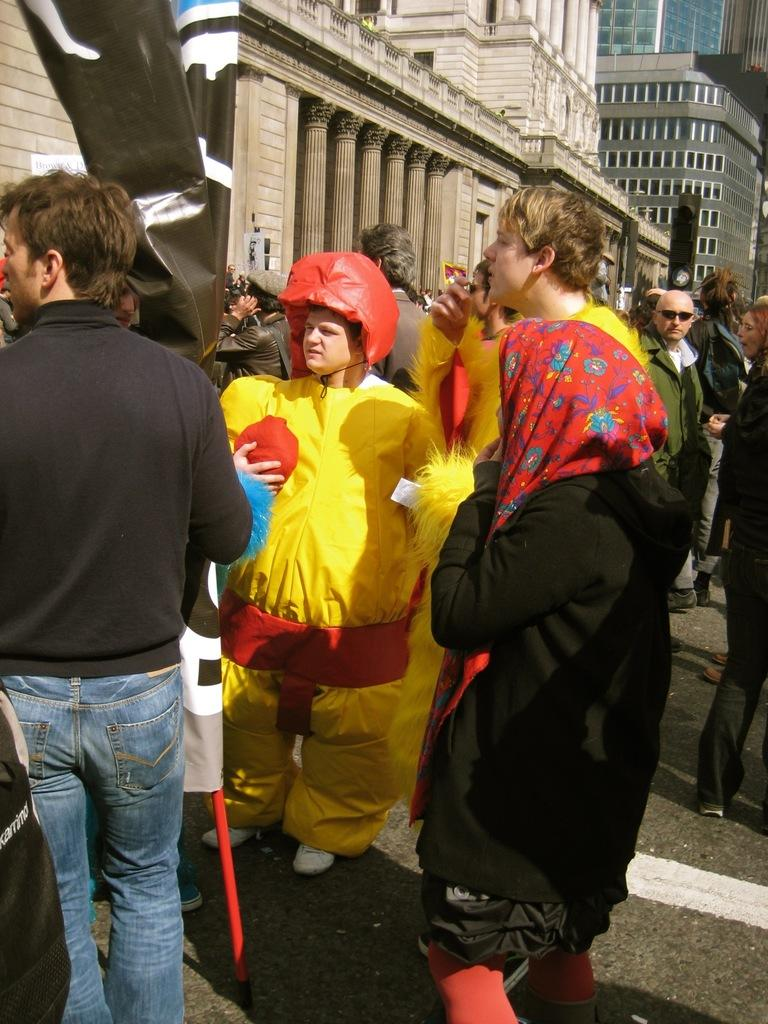What is the main subject in the center of the image? There is a clown in the center of the image. Where are the people located in the image? There are people on both the right and left sides of the image. What can be seen in the background of the image? There are buildings at the top side of the image. What type of error can be seen on the map in the image? There is no map present in the image, so it is not possible to determine if there is an error. 